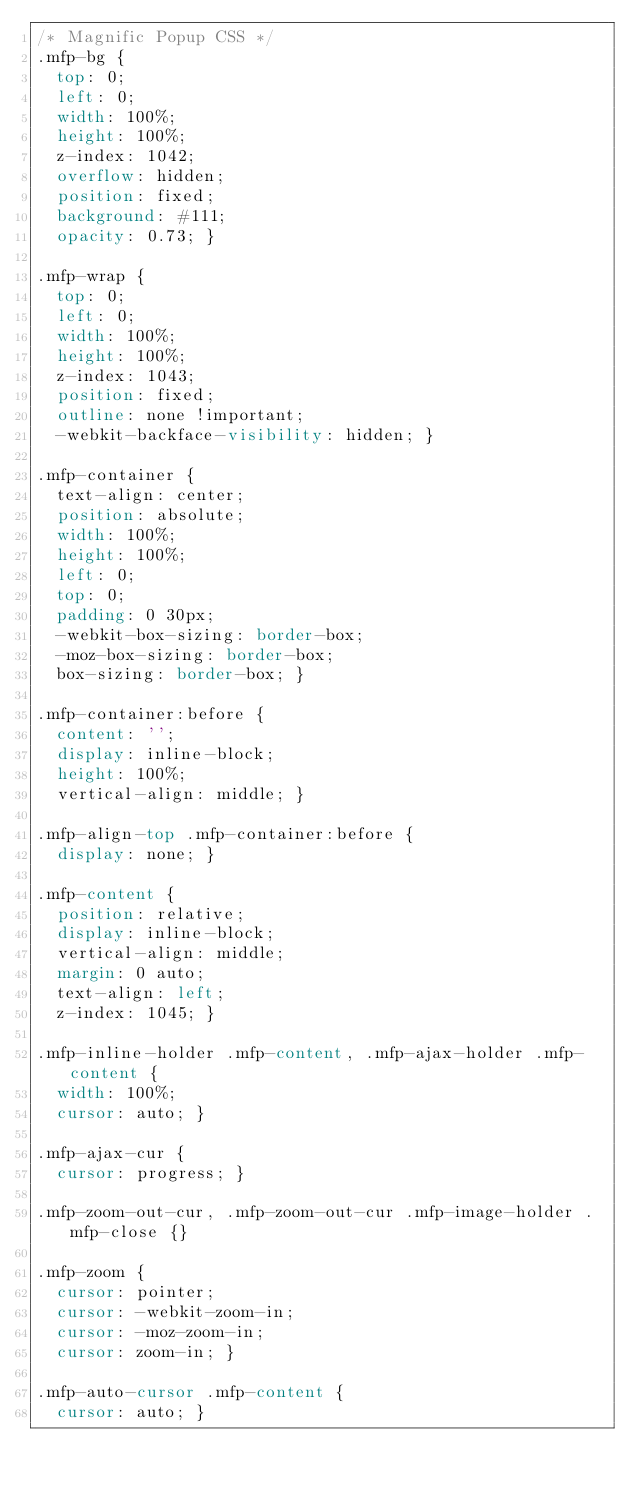Convert code to text. <code><loc_0><loc_0><loc_500><loc_500><_CSS_>/* Magnific Popup CSS */
.mfp-bg {
  top: 0;
  left: 0;
  width: 100%;
  height: 100%;
  z-index: 1042;
  overflow: hidden;
  position: fixed;
  background: #111;
  opacity: 0.73; }

.mfp-wrap {
  top: 0;
  left: 0;
  width: 100%;
  height: 100%;
  z-index: 1043;
  position: fixed;
  outline: none !important;
  -webkit-backface-visibility: hidden; }

.mfp-container {
  text-align: center;
  position: absolute;
  width: 100%;
  height: 100%;
  left: 0;
  top: 0;
  padding: 0 30px;
  -webkit-box-sizing: border-box;
  -moz-box-sizing: border-box;
  box-sizing: border-box; }

.mfp-container:before {
  content: '';
  display: inline-block;
  height: 100%;
  vertical-align: middle; }

.mfp-align-top .mfp-container:before {
  display: none; }

.mfp-content {
  position: relative;
  display: inline-block;
  vertical-align: middle;
  margin: 0 auto;
  text-align: left;
  z-index: 1045; }

.mfp-inline-holder .mfp-content, .mfp-ajax-holder .mfp-content {
  width: 100%;
  cursor: auto; }

.mfp-ajax-cur {
  cursor: progress; }

.mfp-zoom-out-cur, .mfp-zoom-out-cur .mfp-image-holder .mfp-close {}

.mfp-zoom {
  cursor: pointer;
  cursor: -webkit-zoom-in;
  cursor: -moz-zoom-in;
  cursor: zoom-in; }

.mfp-auto-cursor .mfp-content {
  cursor: auto; }
</code> 